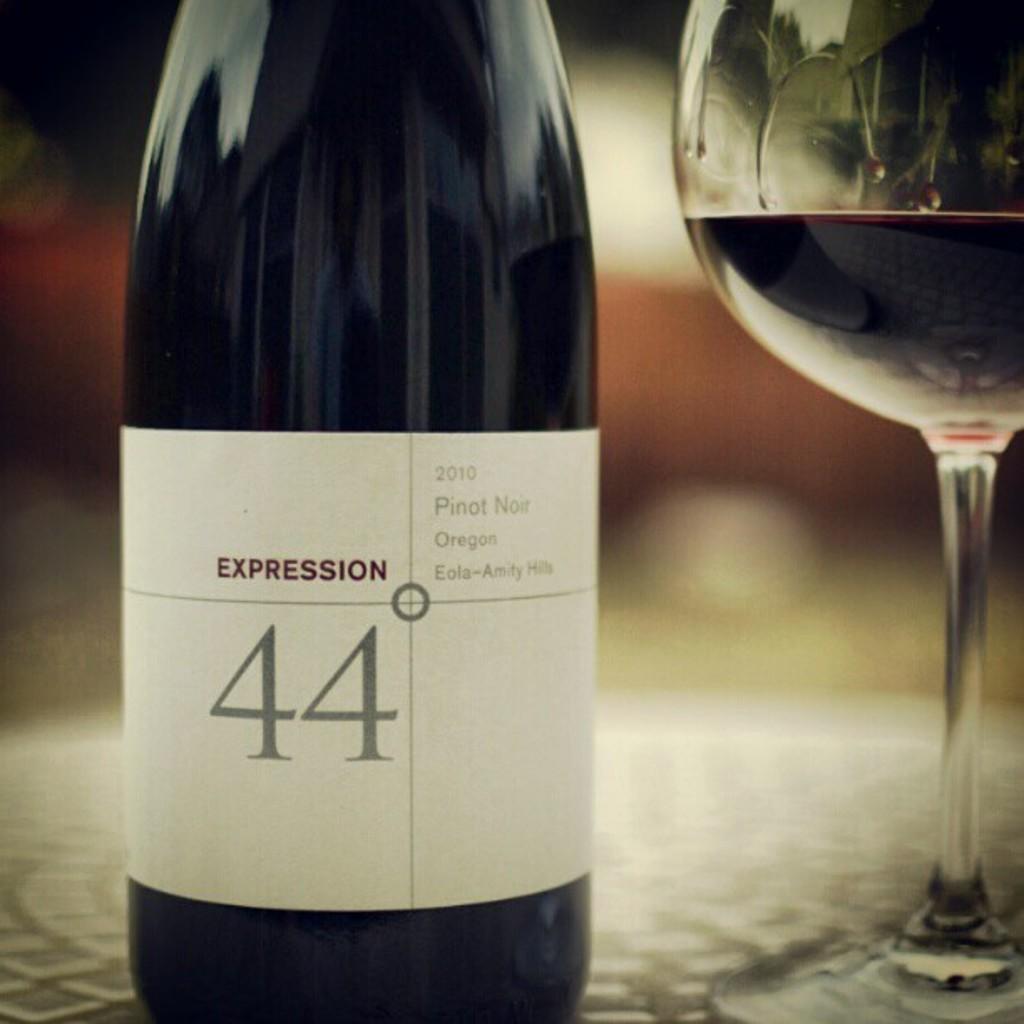What is the name of this wine?
Make the answer very short. Expression 44. What kind of wine is this?
Give a very brief answer. Pinot noir. 